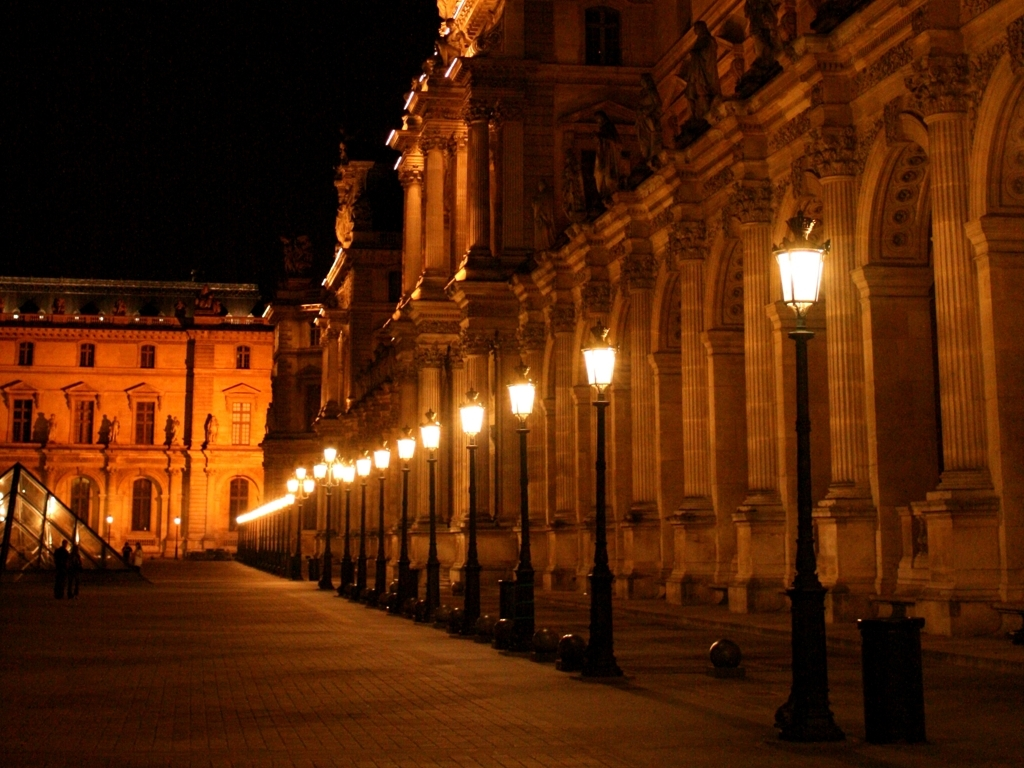What time of day do you think this photo was taken? Given the dark sky and the prominence of artificial lighting in the scene, it is likely that the photo was taken during the evening or at night, after sunset. 